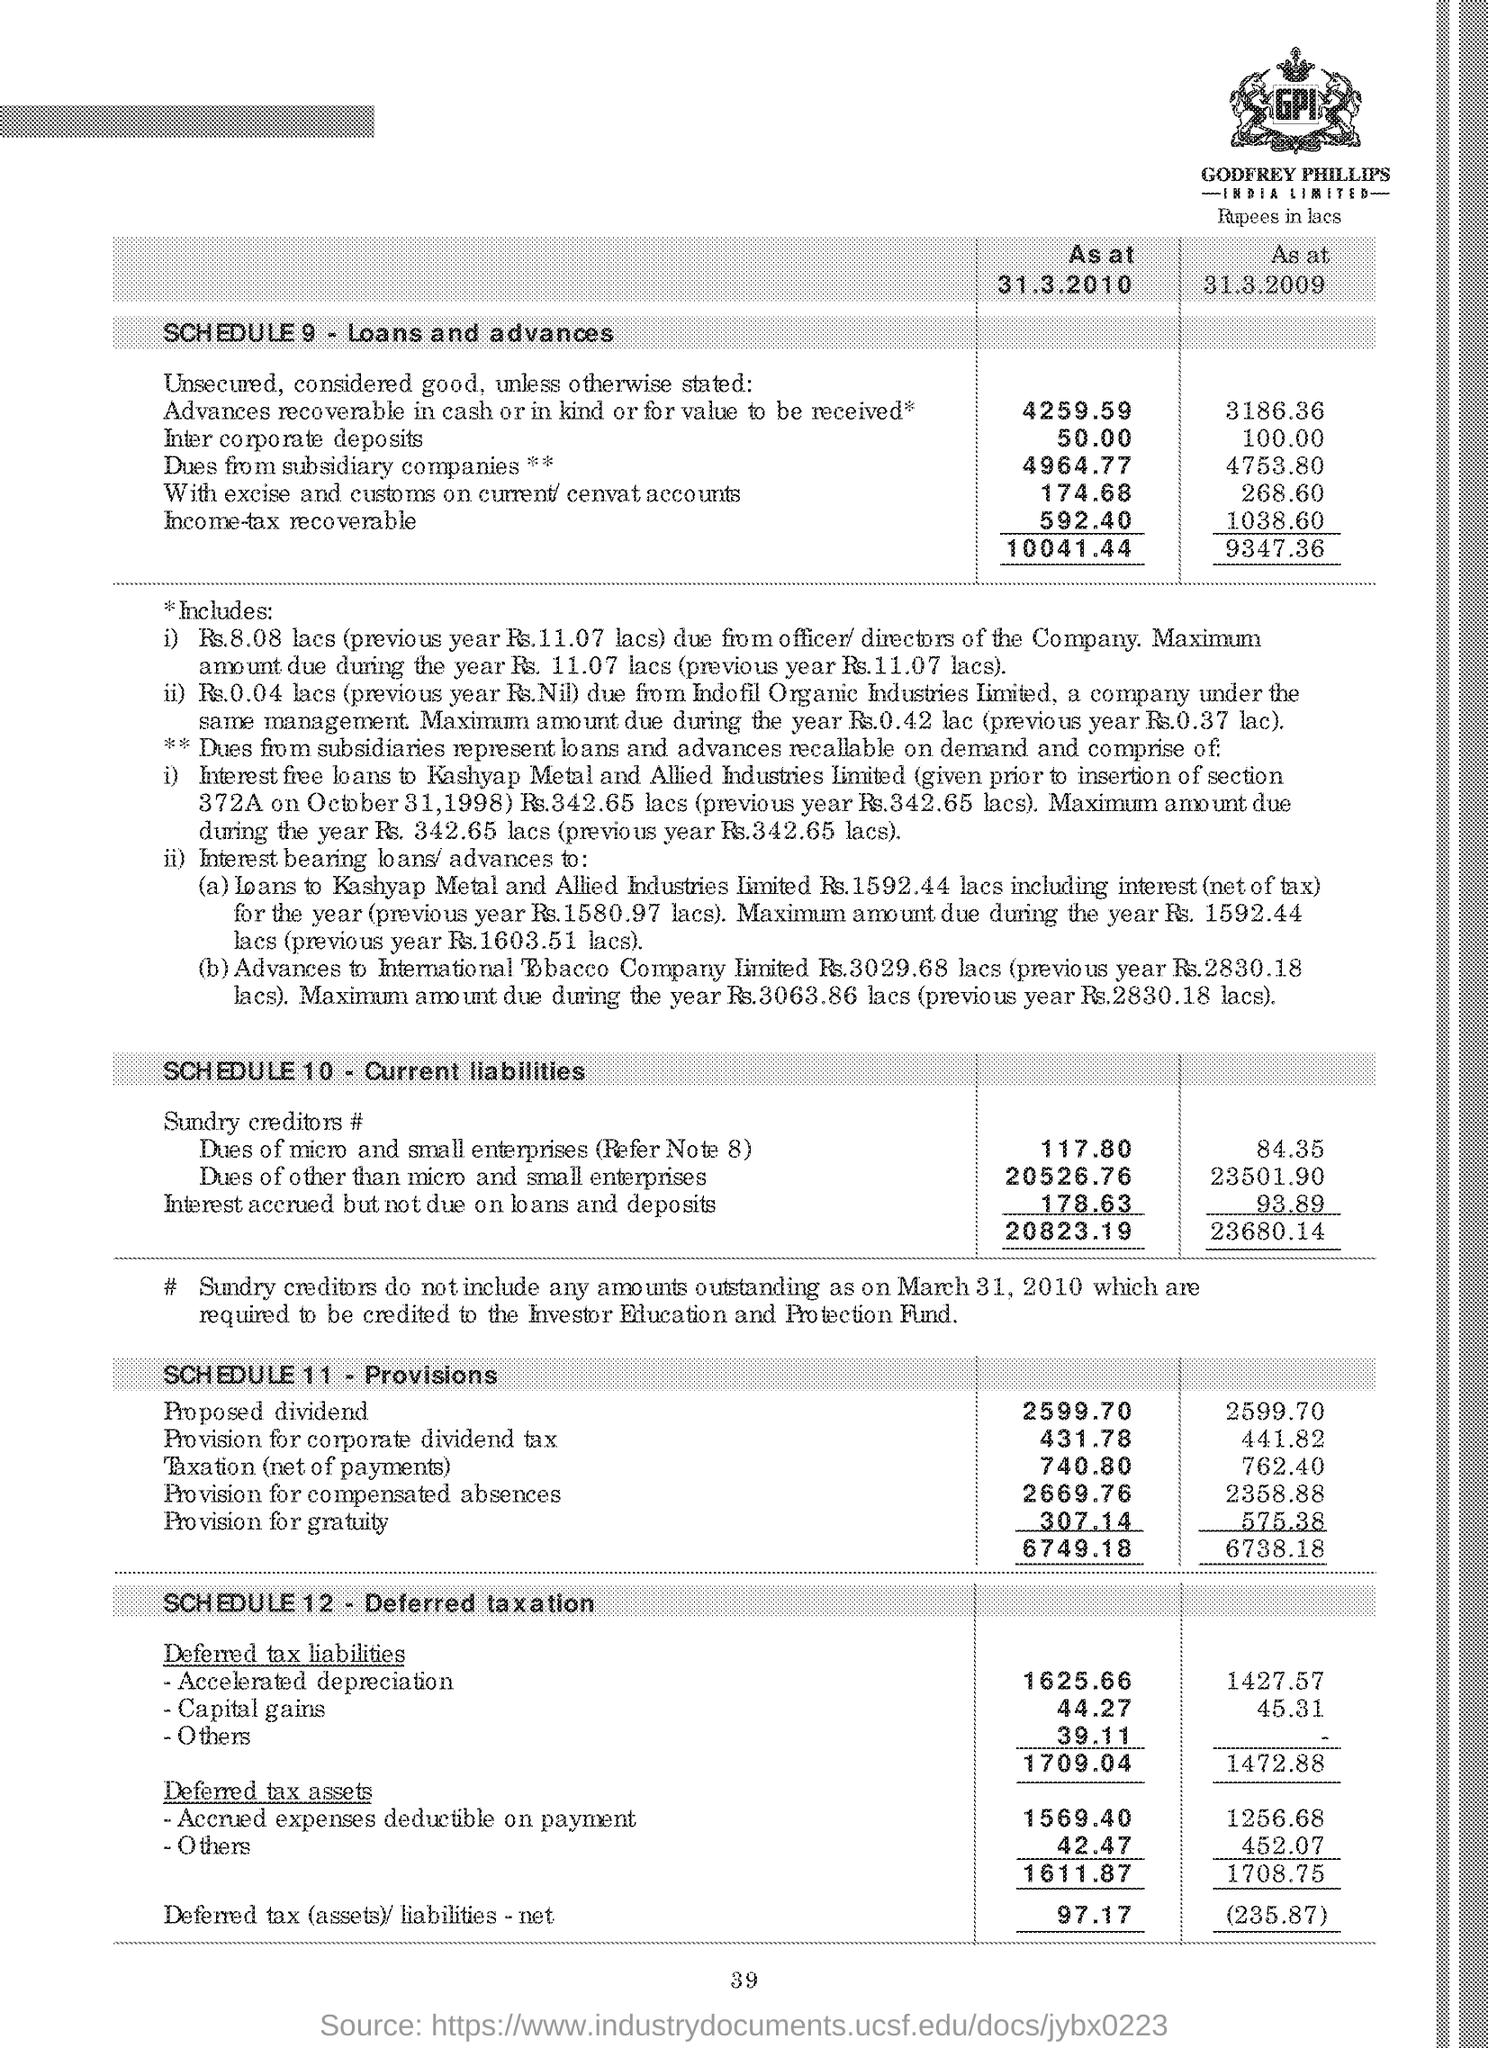Mention a couple of crucial points in this snapshot. The text written in this image is 'GPI...' 